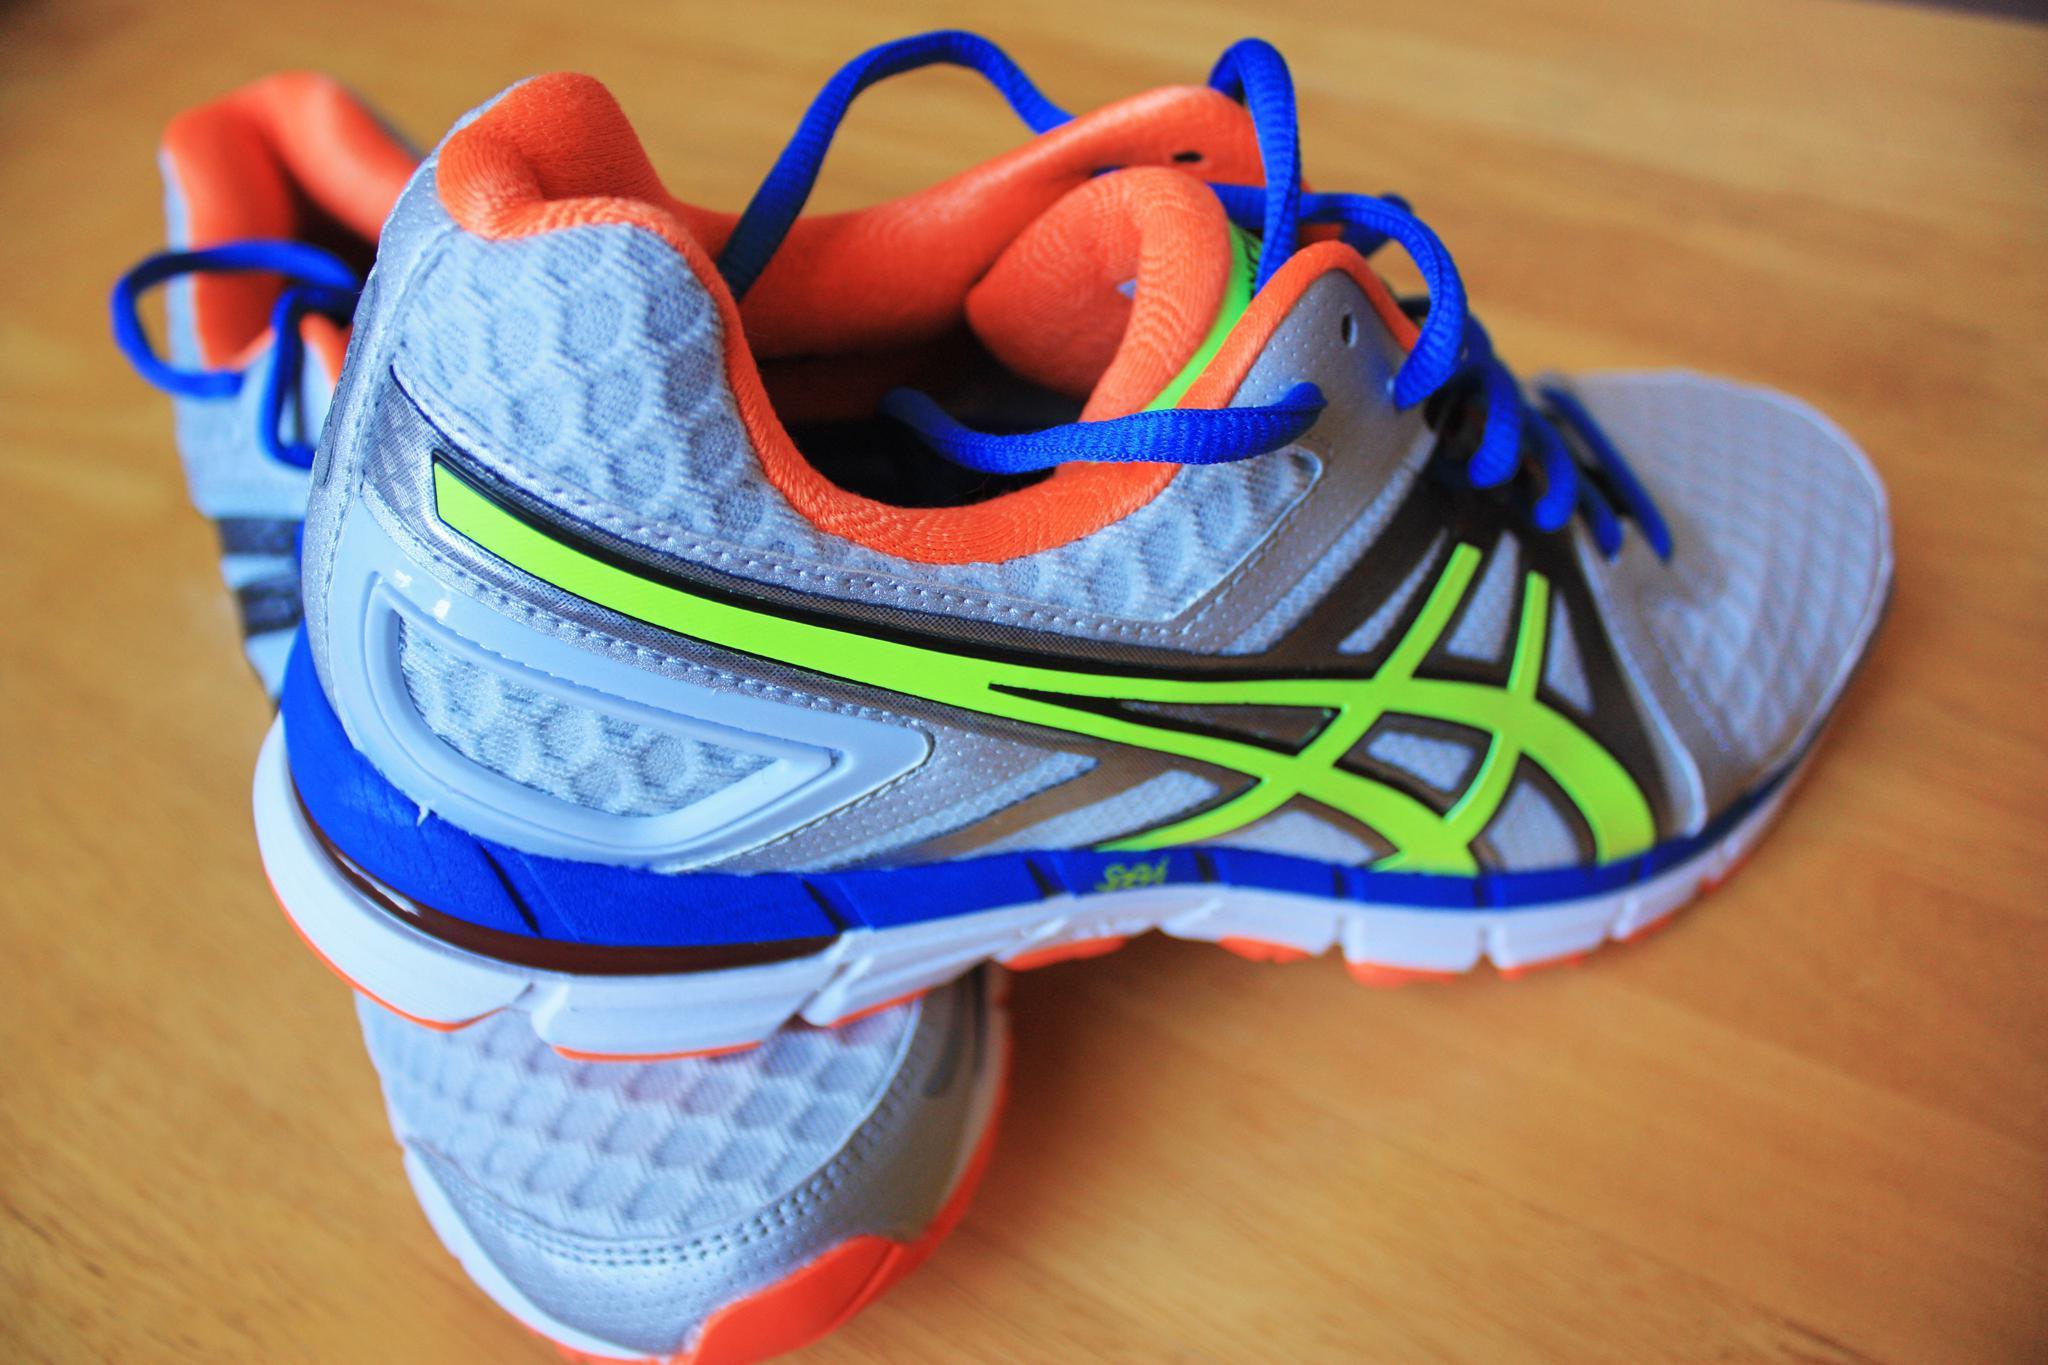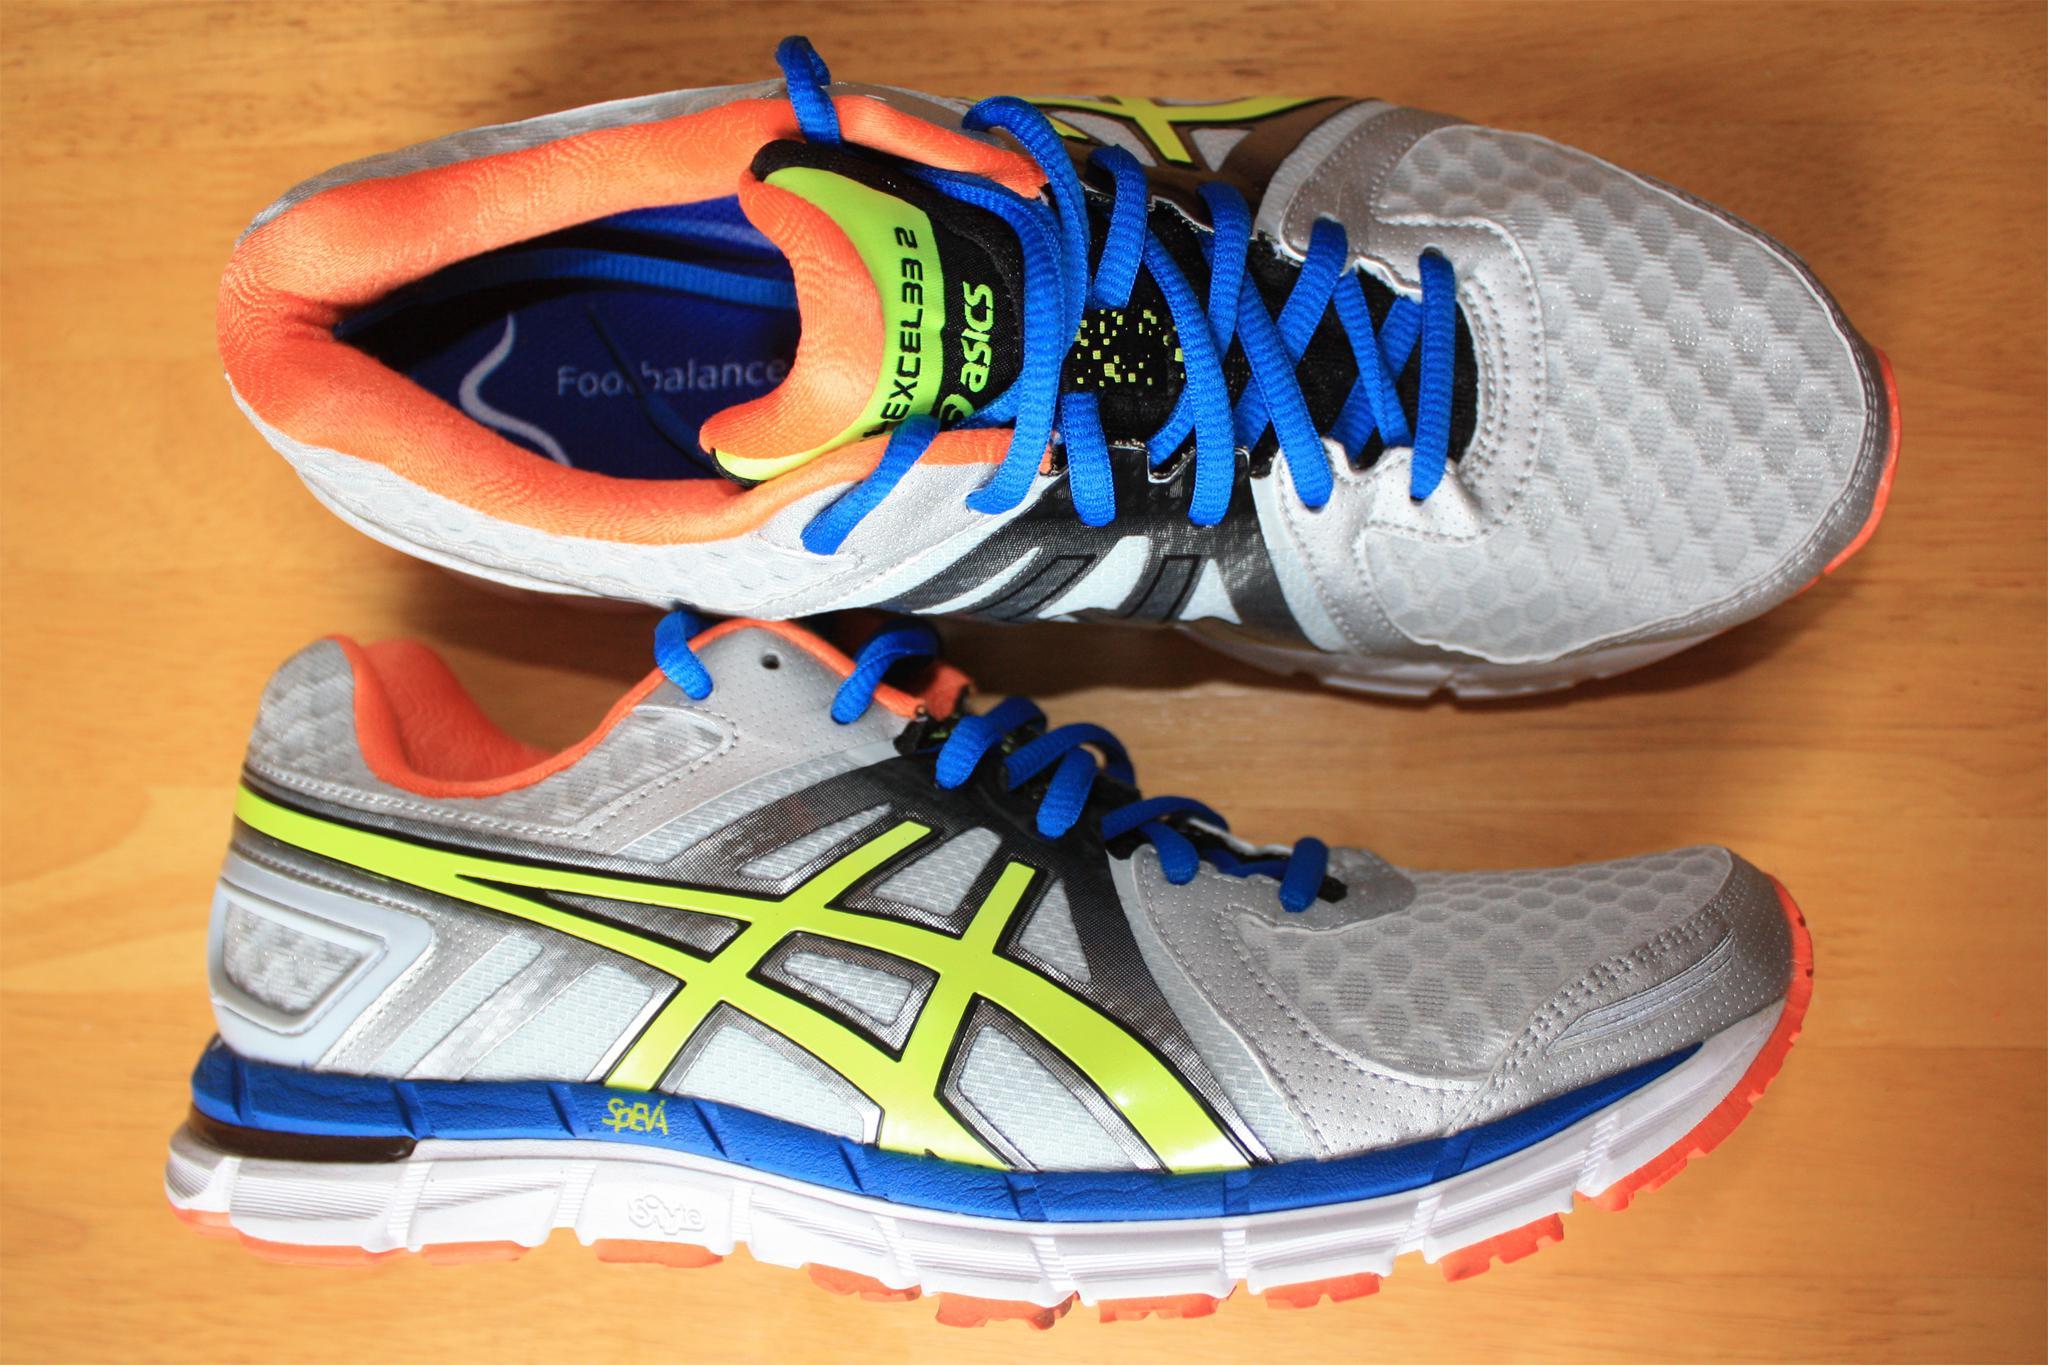The first image is the image on the left, the second image is the image on the right. Examine the images to the left and right. Is the description "At least one shoe is purple with white and orange trim." accurate? Answer yes or no. No. The first image is the image on the left, the second image is the image on the right. Assess this claim about the two images: "the shoe in the image on the left is black". Correct or not? Answer yes or no. No. 